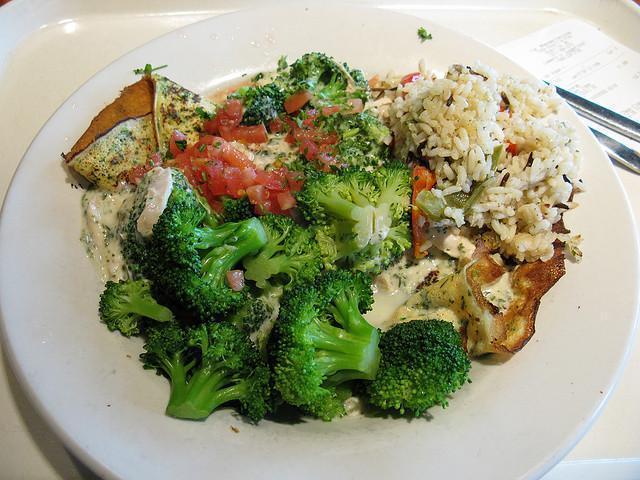How many broccolis are visible?
Give a very brief answer. 2. 